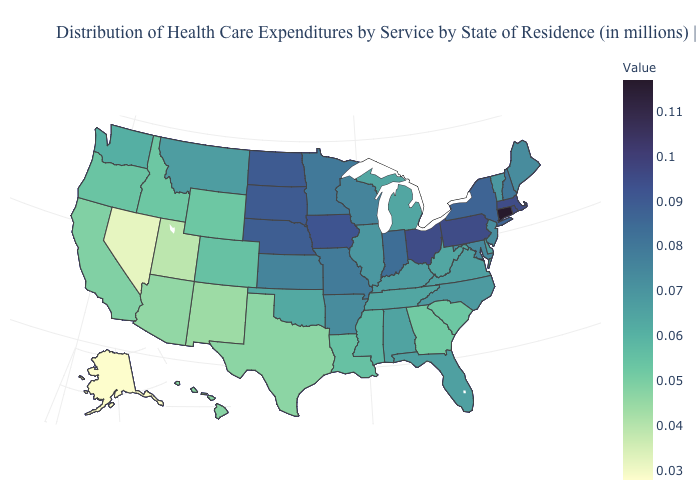Does Montana have the highest value in the West?
Concise answer only. Yes. Does New York have a lower value than Rhode Island?
Short answer required. Yes. Among the states that border New Mexico , which have the lowest value?
Answer briefly. Utah. Is the legend a continuous bar?
Write a very short answer. Yes. Which states have the lowest value in the USA?
Be succinct. Alaska. 